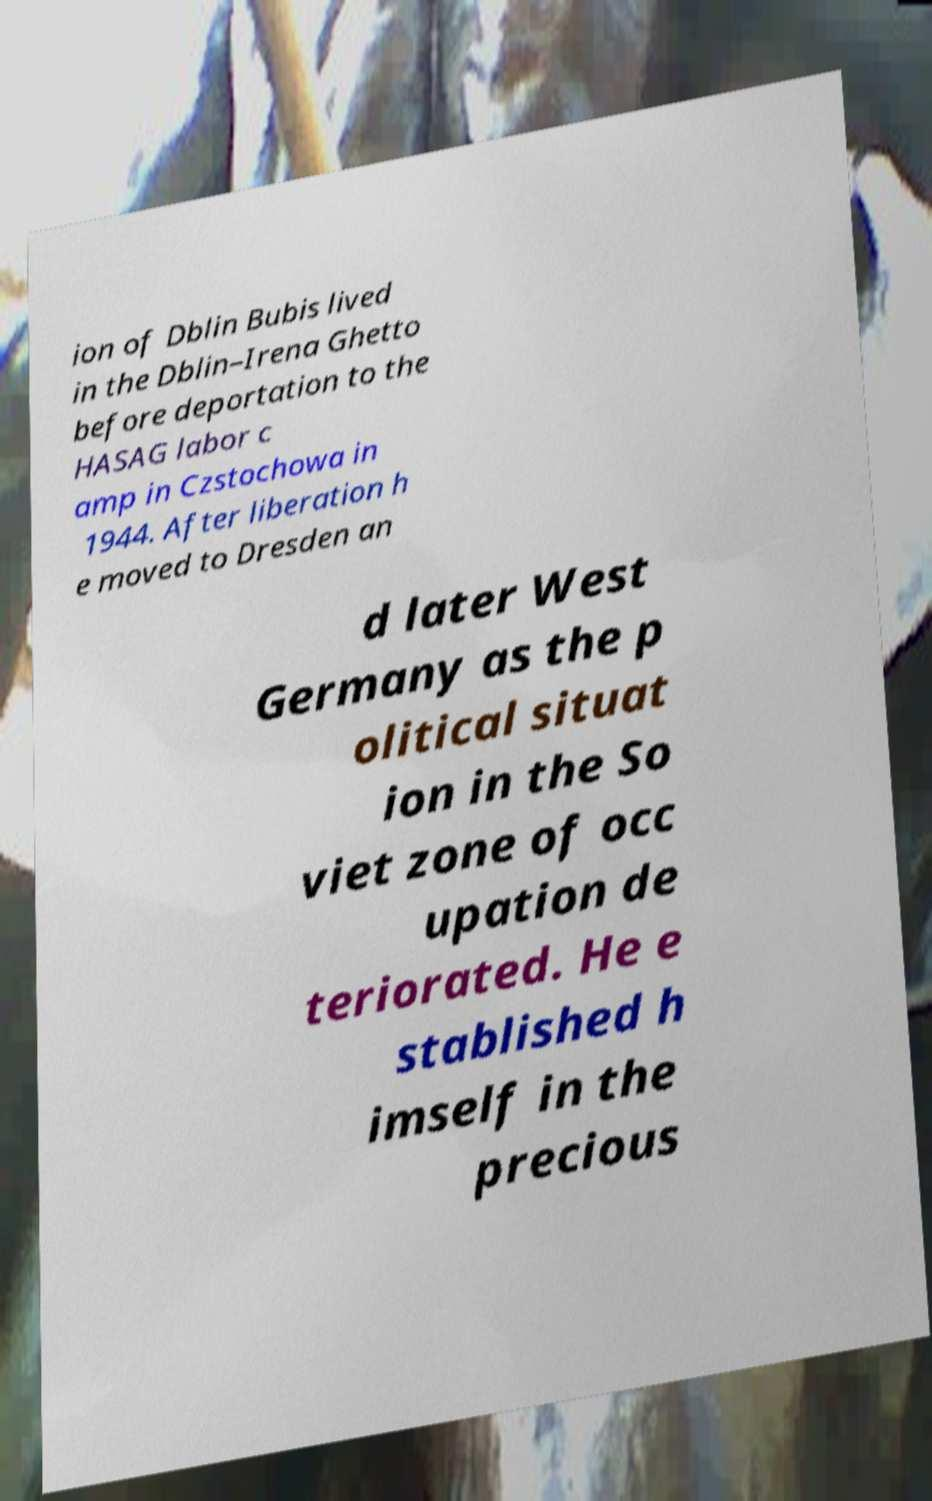I need the written content from this picture converted into text. Can you do that? ion of Dblin Bubis lived in the Dblin–Irena Ghetto before deportation to the HASAG labor c amp in Czstochowa in 1944. After liberation h e moved to Dresden an d later West Germany as the p olitical situat ion in the So viet zone of occ upation de teriorated. He e stablished h imself in the precious 